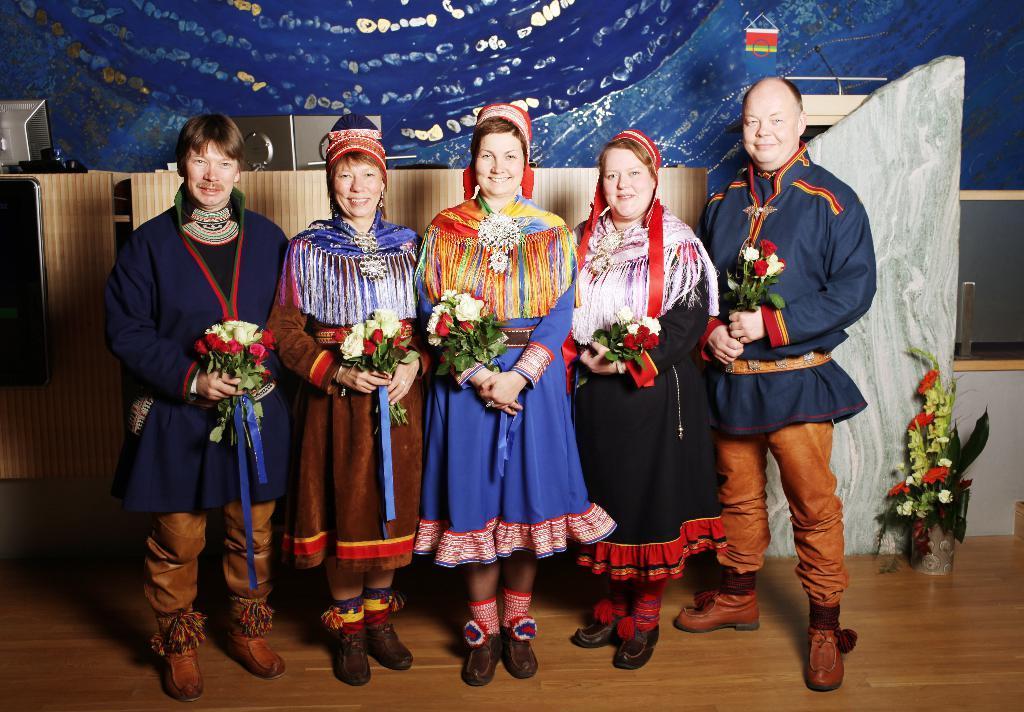In one or two sentences, can you explain what this image depicts? In this picture we can see five people smiling, holding flower bouquets with their hands, standing on the floor and at the back of them we can see a mic, flower bouquet and some objects. 